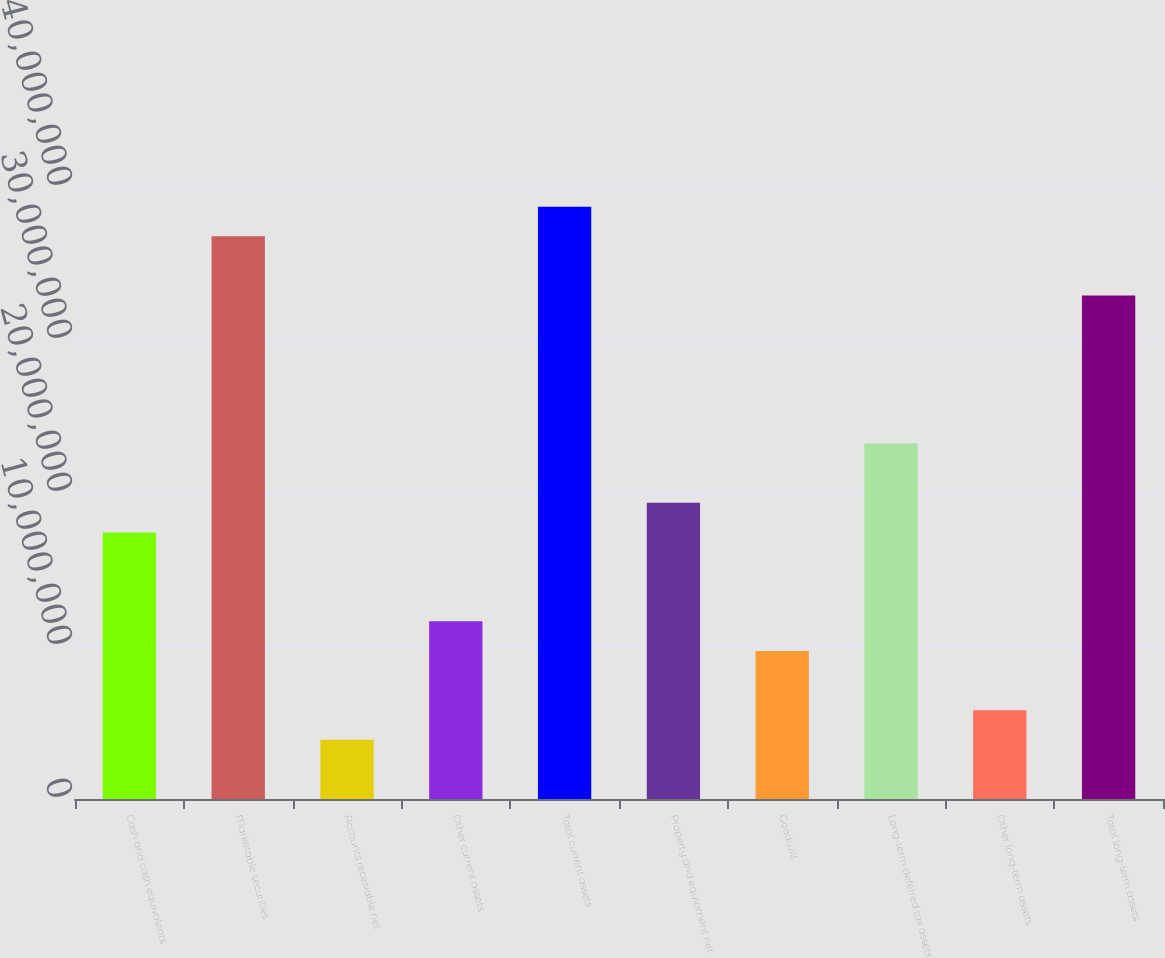Convert chart. <chart><loc_0><loc_0><loc_500><loc_500><bar_chart><fcel>Cash and cash equivalents<fcel>Marketable securities<fcel>Accounts receivable net<fcel>Other current assets<fcel>Total current assets<fcel>Property and equipment net<fcel>Goodwill<fcel>Long-term deferred tax assets<fcel>Other long-term assets<fcel>Total long-term assets<nl><fcel>1.74205e+07<fcel>3.67763e+07<fcel>3.87148e+06<fcel>1.16138e+07<fcel>3.87119e+07<fcel>1.93561e+07<fcel>9.67821e+06<fcel>2.32272e+07<fcel>5.80705e+06<fcel>3.29051e+07<nl></chart> 